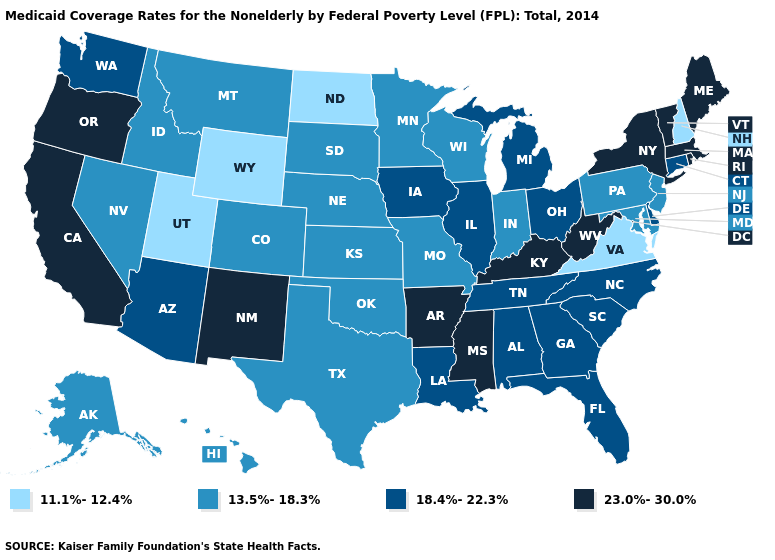Among the states that border Oregon , which have the lowest value?
Concise answer only. Idaho, Nevada. Does Montana have the lowest value in the USA?
Answer briefly. No. Among the states that border New Mexico , which have the lowest value?
Quick response, please. Utah. Name the states that have a value in the range 23.0%-30.0%?
Answer briefly. Arkansas, California, Kentucky, Maine, Massachusetts, Mississippi, New Mexico, New York, Oregon, Rhode Island, Vermont, West Virginia. What is the highest value in the Northeast ?
Keep it brief. 23.0%-30.0%. Does the map have missing data?
Concise answer only. No. Among the states that border Vermont , does Massachusetts have the lowest value?
Short answer required. No. Is the legend a continuous bar?
Be succinct. No. What is the value of Iowa?
Answer briefly. 18.4%-22.3%. Does Connecticut have the lowest value in the USA?
Answer briefly. No. Among the states that border Wisconsin , does Michigan have the highest value?
Keep it brief. Yes. What is the value of Utah?
Answer briefly. 11.1%-12.4%. Does Ohio have the highest value in the MidWest?
Write a very short answer. Yes. Does the map have missing data?
Keep it brief. No. Which states have the highest value in the USA?
Write a very short answer. Arkansas, California, Kentucky, Maine, Massachusetts, Mississippi, New Mexico, New York, Oregon, Rhode Island, Vermont, West Virginia. 